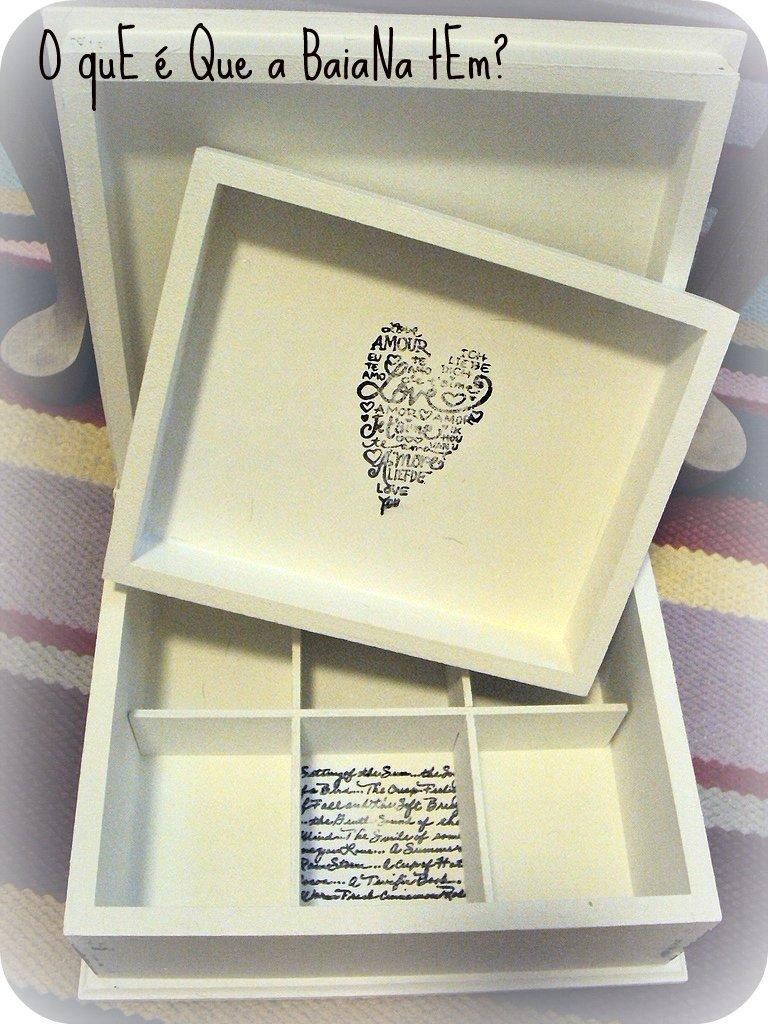<image>
Describe the image concisely. A shape of a heart is filled with letters and has "Love" in the center of it. 